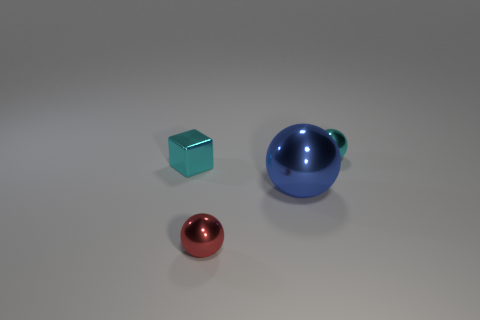Add 4 blue balls. How many objects exist? 8 Subtract all spheres. How many objects are left? 1 Add 2 green shiny cubes. How many green shiny cubes exist? 2 Subtract 1 cyan blocks. How many objects are left? 3 Subtract all large cylinders. Subtract all large metal objects. How many objects are left? 3 Add 4 red balls. How many red balls are left? 5 